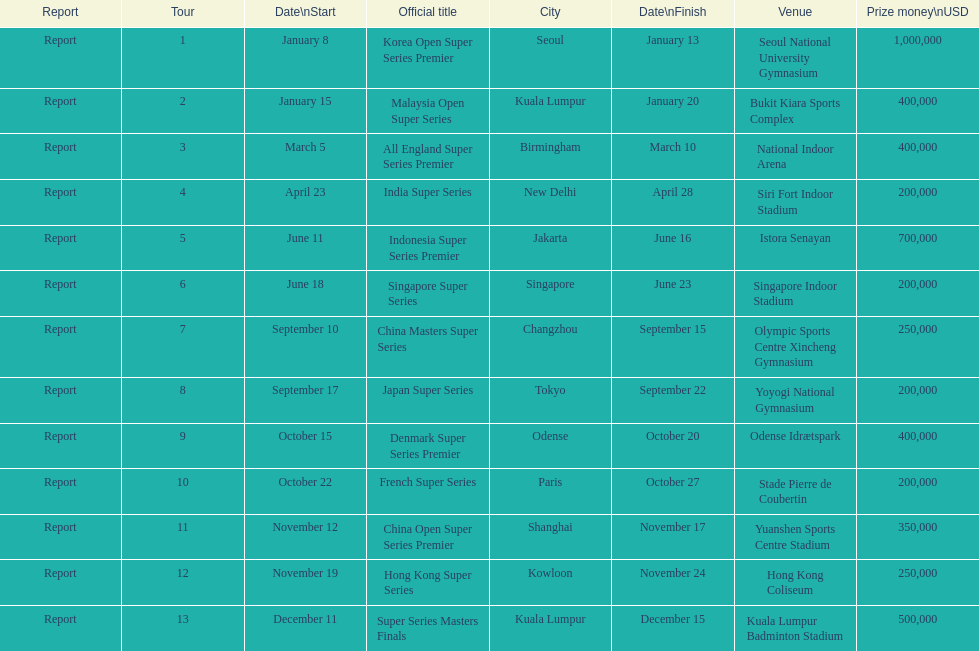How many days does the japan super series last? 5. 